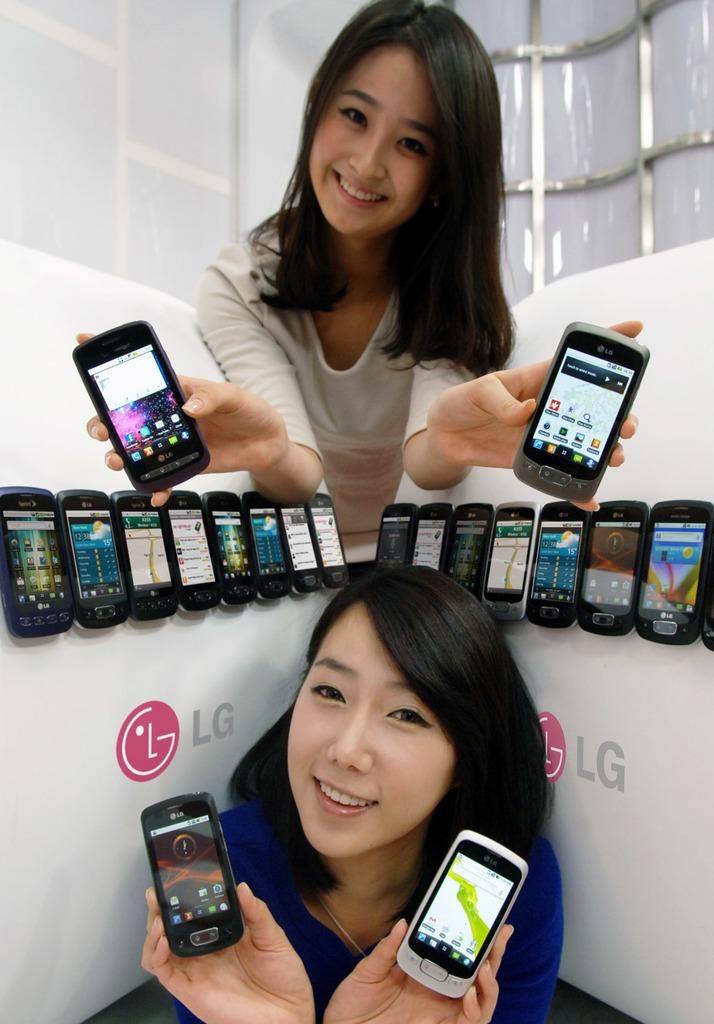How many people are in the image? There are two girls in the image. What are the girls doing in the image? The girls are smiling and holding a mobile phone. What might be the purpose of the mobile phone in the image? The girls might be using the mobile phone to take a selfie or capture a moment, as they are posing for a camera. What can be seen in the background of the image? There is a whiteboard wall in the background of the image. Can you tell me how many flies are buzzing around the girls in the image? There are no flies visible in the image. What type of bulb is illuminating the girls in the image? There is no specific bulb mentioned or visible in the image. 